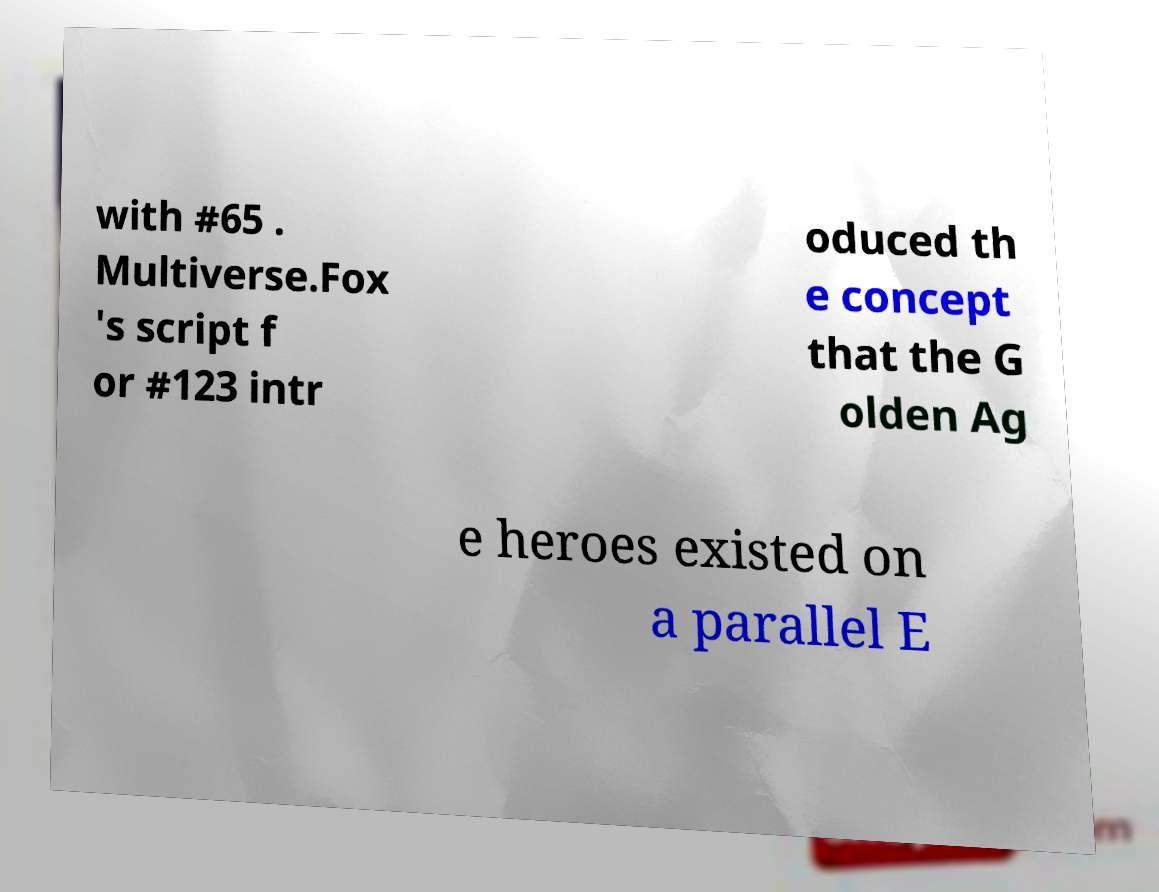Please read and relay the text visible in this image. What does it say? with #65 . Multiverse.Fox 's script f or #123 intr oduced th e concept that the G olden Ag e heroes existed on a parallel E 